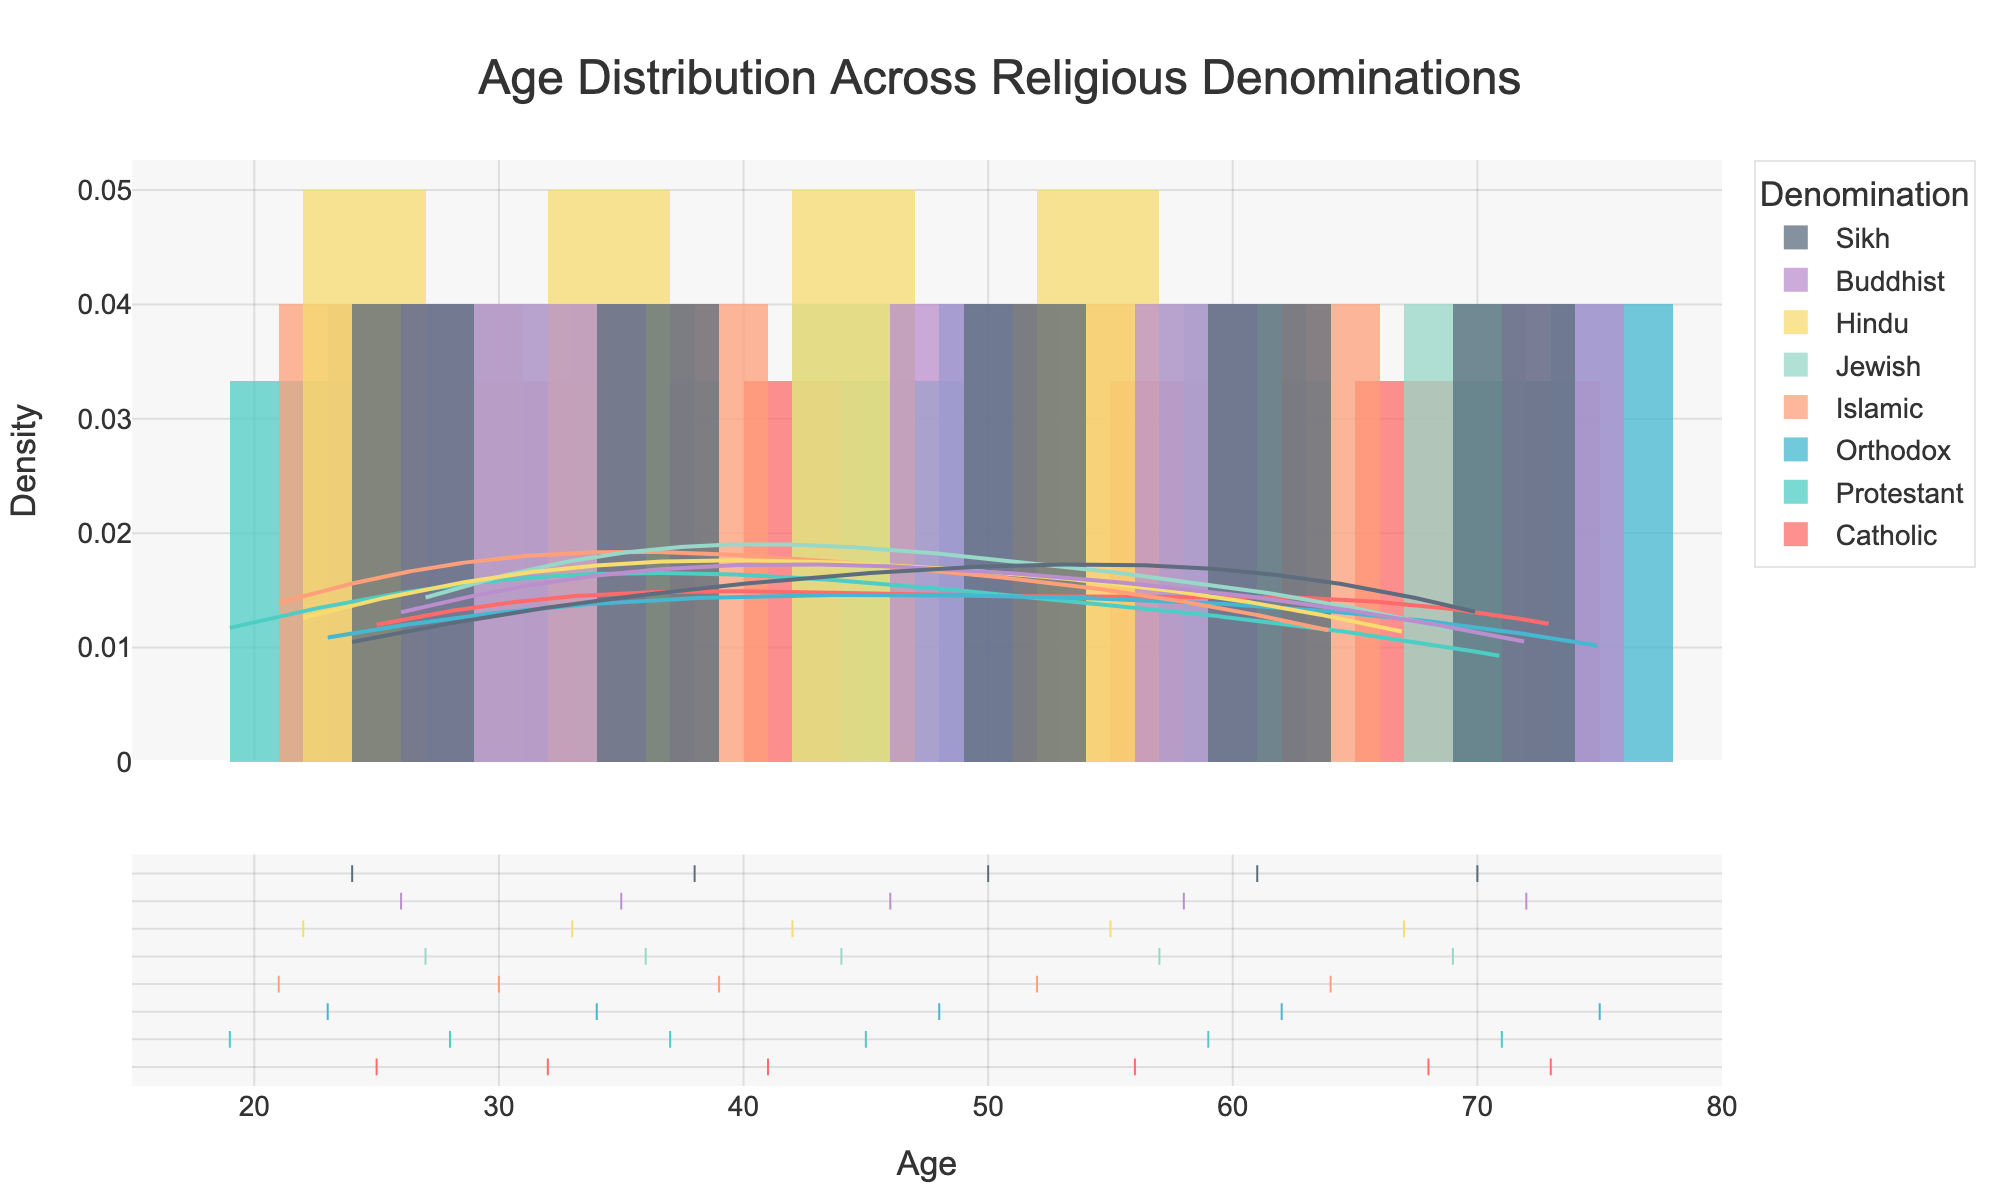What is the title of the plot? The title of the plot is located at the top center of the figure and is clearly marked. It provides a summary of what the plot is depicting.
Answer: Age Distribution Across Religious Denominations What does the x-axis represent? The x-axis, which spans horizontally at the bottom of the plot, represents the "Age" of individuals attending religious services.
Answer: Age How many denominations are represented in the plot? There are multiple legend entries each representing a denomination. Upon counting, there are seven denominations listed.
Answer: Seven Which denomination has the highest peak in the KDE curve? The KDE curves show the density estimation for each denomination. By observing the highest peak among these curves, the Protestant denomination can be identified as having the highest peak.
Answer: Protestant What age does the KDE curve for the Catholic denomination peak? By looking at the KDE curve labeled "Catholic," the peak appears to be around the age of approximately 73.
Answer: 73 Which denomination shows a density peak around age 46? Observing the KDE curves, the peak around age 46 corresponds to the Buddhist denomination.
Answer: Buddhist Among Islamic and Jewish denominations, which has a broader age distribution? Broader age distribution can be understood by looking at the spread of the KDE curve. The Islamic denomination's curve appears more spread out than the Jewish denomination's curve.
Answer: Islamic What is the age range for the category displayed in the plot? The age range can be inferred from the x-axis displayed grid markers. The range starts from 15 and ends at 80 years.
Answer: 15 to 80 years Which denominations have age distributions that peak above 60 years? By examining the KDE curves, denominations peaking above 60 years are Catholic, Protestant, Orthodox, and Sikh.
Answer: Catholic, Protestant, Orthodox, Sikh Comparing Hindu and Jewish denominations, which has individuals attending the services at an older age? Observing the KDE curves, the Hindu denomination peaks at around 67, whereas the Jewish denomination peaks at around 69. Thus, Jewish has attendees at an older age.
Answer: Jewish 